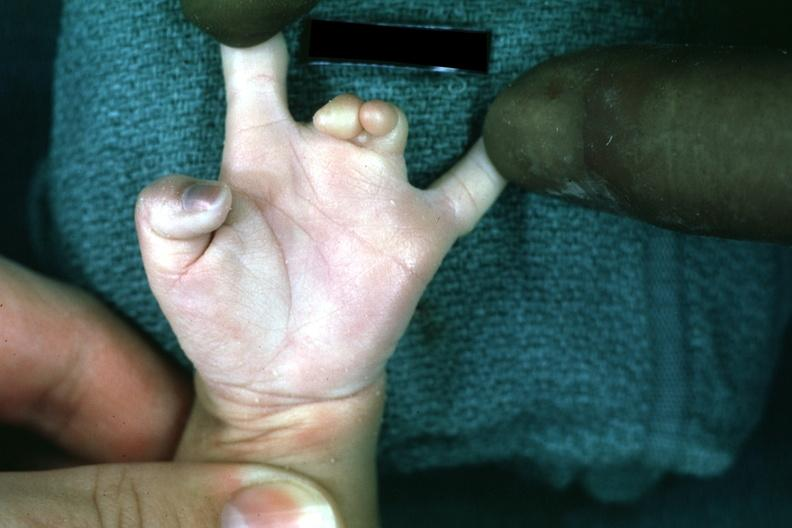what are present?
Answer the question using a single word or phrase. Extremities 